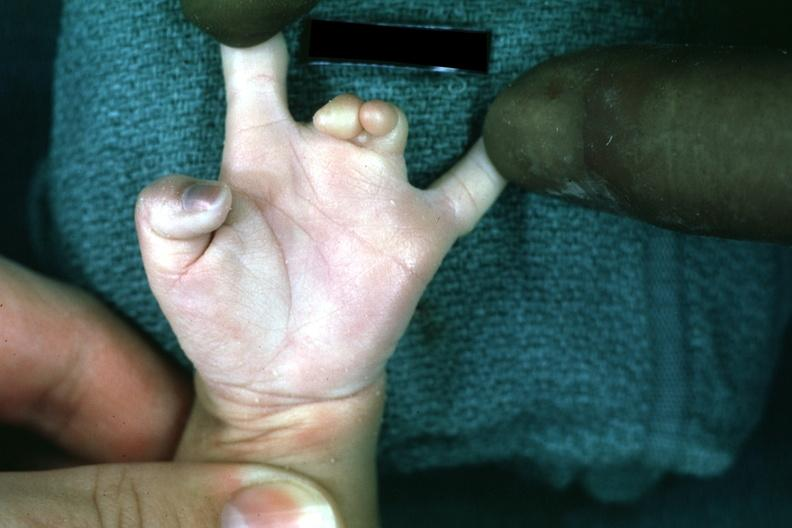what are present?
Answer the question using a single word or phrase. Extremities 